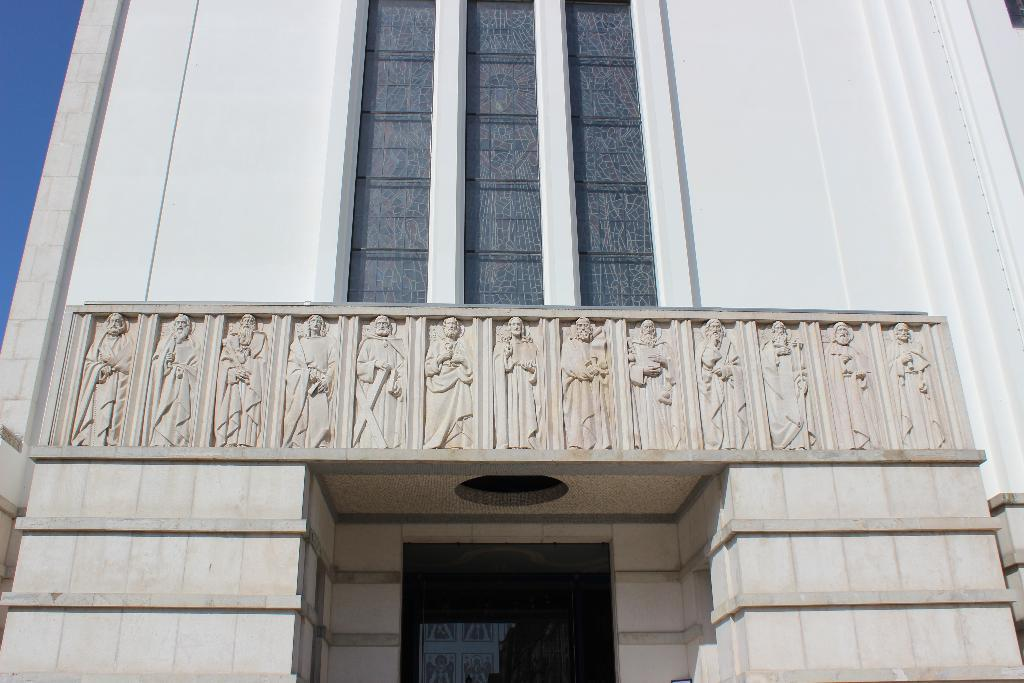What type of structure is present in the image? There is a building in the image. What feature can be seen on the building? There are glass doors in the building. What type of artwork is present on the building? There are sculptures on the wall of the building. What is visible in the background of the image? The sky is visible in the image. How many trains can be seen passing by the building in the image? There are no trains visible in the image. What type of range is present in the image? There is no range present in the image. 